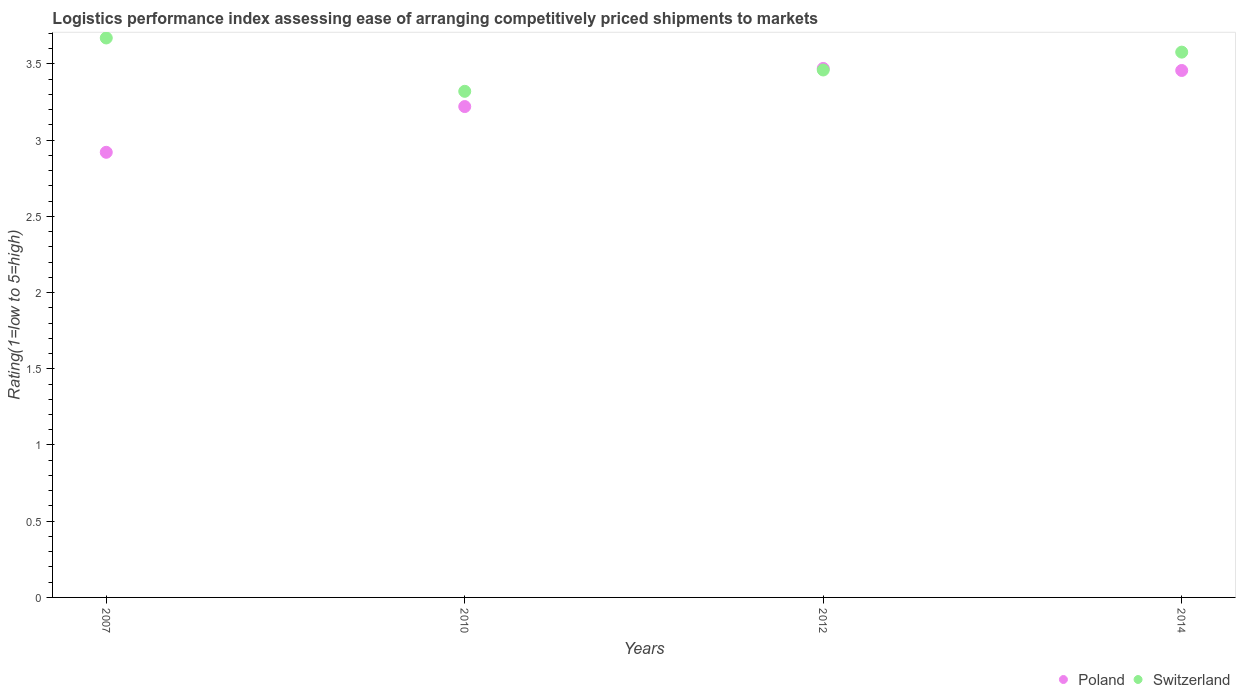Is the number of dotlines equal to the number of legend labels?
Make the answer very short. Yes. What is the Logistic performance index in Switzerland in 2007?
Provide a short and direct response. 3.67. Across all years, what is the maximum Logistic performance index in Switzerland?
Provide a succinct answer. 3.67. Across all years, what is the minimum Logistic performance index in Switzerland?
Offer a terse response. 3.32. In which year was the Logistic performance index in Switzerland maximum?
Your response must be concise. 2007. What is the total Logistic performance index in Switzerland in the graph?
Your answer should be very brief. 14.03. What is the difference between the Logistic performance index in Switzerland in 2007 and that in 2014?
Provide a short and direct response. 0.09. What is the difference between the Logistic performance index in Switzerland in 2007 and the Logistic performance index in Poland in 2012?
Provide a succinct answer. 0.2. What is the average Logistic performance index in Poland per year?
Offer a terse response. 3.27. In the year 2014, what is the difference between the Logistic performance index in Switzerland and Logistic performance index in Poland?
Offer a terse response. 0.12. In how many years, is the Logistic performance index in Switzerland greater than 3?
Make the answer very short. 4. What is the ratio of the Logistic performance index in Switzerland in 2007 to that in 2010?
Keep it short and to the point. 1.11. What is the difference between the highest and the second highest Logistic performance index in Switzerland?
Ensure brevity in your answer.  0.09. What is the difference between the highest and the lowest Logistic performance index in Poland?
Ensure brevity in your answer.  0.55. In how many years, is the Logistic performance index in Poland greater than the average Logistic performance index in Poland taken over all years?
Give a very brief answer. 2. Does the Logistic performance index in Poland monotonically increase over the years?
Ensure brevity in your answer.  No. Is the Logistic performance index in Poland strictly less than the Logistic performance index in Switzerland over the years?
Make the answer very short. No. How many dotlines are there?
Your answer should be very brief. 2. How many years are there in the graph?
Your answer should be very brief. 4. Are the values on the major ticks of Y-axis written in scientific E-notation?
Provide a succinct answer. No. How are the legend labels stacked?
Give a very brief answer. Horizontal. What is the title of the graph?
Your answer should be compact. Logistics performance index assessing ease of arranging competitively priced shipments to markets. Does "El Salvador" appear as one of the legend labels in the graph?
Ensure brevity in your answer.  No. What is the label or title of the X-axis?
Keep it short and to the point. Years. What is the label or title of the Y-axis?
Offer a terse response. Rating(1=low to 5=high). What is the Rating(1=low to 5=high) of Poland in 2007?
Ensure brevity in your answer.  2.92. What is the Rating(1=low to 5=high) in Switzerland in 2007?
Provide a succinct answer. 3.67. What is the Rating(1=low to 5=high) in Poland in 2010?
Ensure brevity in your answer.  3.22. What is the Rating(1=low to 5=high) in Switzerland in 2010?
Provide a short and direct response. 3.32. What is the Rating(1=low to 5=high) of Poland in 2012?
Make the answer very short. 3.47. What is the Rating(1=low to 5=high) of Switzerland in 2012?
Make the answer very short. 3.46. What is the Rating(1=low to 5=high) in Poland in 2014?
Ensure brevity in your answer.  3.46. What is the Rating(1=low to 5=high) in Switzerland in 2014?
Your answer should be very brief. 3.58. Across all years, what is the maximum Rating(1=low to 5=high) of Poland?
Give a very brief answer. 3.47. Across all years, what is the maximum Rating(1=low to 5=high) in Switzerland?
Provide a short and direct response. 3.67. Across all years, what is the minimum Rating(1=low to 5=high) in Poland?
Provide a succinct answer. 2.92. Across all years, what is the minimum Rating(1=low to 5=high) in Switzerland?
Provide a succinct answer. 3.32. What is the total Rating(1=low to 5=high) of Poland in the graph?
Keep it short and to the point. 13.07. What is the total Rating(1=low to 5=high) in Switzerland in the graph?
Offer a terse response. 14.03. What is the difference between the Rating(1=low to 5=high) of Poland in 2007 and that in 2010?
Your response must be concise. -0.3. What is the difference between the Rating(1=low to 5=high) of Switzerland in 2007 and that in 2010?
Your answer should be very brief. 0.35. What is the difference between the Rating(1=low to 5=high) of Poland in 2007 and that in 2012?
Make the answer very short. -0.55. What is the difference between the Rating(1=low to 5=high) of Switzerland in 2007 and that in 2012?
Provide a short and direct response. 0.21. What is the difference between the Rating(1=low to 5=high) of Poland in 2007 and that in 2014?
Your answer should be very brief. -0.54. What is the difference between the Rating(1=low to 5=high) in Switzerland in 2007 and that in 2014?
Your answer should be very brief. 0.09. What is the difference between the Rating(1=low to 5=high) of Switzerland in 2010 and that in 2012?
Your answer should be compact. -0.14. What is the difference between the Rating(1=low to 5=high) of Poland in 2010 and that in 2014?
Offer a terse response. -0.24. What is the difference between the Rating(1=low to 5=high) of Switzerland in 2010 and that in 2014?
Provide a succinct answer. -0.26. What is the difference between the Rating(1=low to 5=high) in Poland in 2012 and that in 2014?
Keep it short and to the point. 0.01. What is the difference between the Rating(1=low to 5=high) of Switzerland in 2012 and that in 2014?
Your answer should be very brief. -0.12. What is the difference between the Rating(1=low to 5=high) of Poland in 2007 and the Rating(1=low to 5=high) of Switzerland in 2010?
Provide a succinct answer. -0.4. What is the difference between the Rating(1=low to 5=high) of Poland in 2007 and the Rating(1=low to 5=high) of Switzerland in 2012?
Keep it short and to the point. -0.54. What is the difference between the Rating(1=low to 5=high) in Poland in 2007 and the Rating(1=low to 5=high) in Switzerland in 2014?
Ensure brevity in your answer.  -0.66. What is the difference between the Rating(1=low to 5=high) in Poland in 2010 and the Rating(1=low to 5=high) in Switzerland in 2012?
Provide a succinct answer. -0.24. What is the difference between the Rating(1=low to 5=high) of Poland in 2010 and the Rating(1=low to 5=high) of Switzerland in 2014?
Your answer should be compact. -0.36. What is the difference between the Rating(1=low to 5=high) in Poland in 2012 and the Rating(1=low to 5=high) in Switzerland in 2014?
Ensure brevity in your answer.  -0.11. What is the average Rating(1=low to 5=high) in Poland per year?
Make the answer very short. 3.27. What is the average Rating(1=low to 5=high) of Switzerland per year?
Give a very brief answer. 3.51. In the year 2007, what is the difference between the Rating(1=low to 5=high) of Poland and Rating(1=low to 5=high) of Switzerland?
Offer a very short reply. -0.75. In the year 2014, what is the difference between the Rating(1=low to 5=high) in Poland and Rating(1=low to 5=high) in Switzerland?
Make the answer very short. -0.12. What is the ratio of the Rating(1=low to 5=high) of Poland in 2007 to that in 2010?
Keep it short and to the point. 0.91. What is the ratio of the Rating(1=low to 5=high) in Switzerland in 2007 to that in 2010?
Your answer should be very brief. 1.11. What is the ratio of the Rating(1=low to 5=high) in Poland in 2007 to that in 2012?
Your answer should be very brief. 0.84. What is the ratio of the Rating(1=low to 5=high) of Switzerland in 2007 to that in 2012?
Offer a very short reply. 1.06. What is the ratio of the Rating(1=low to 5=high) of Poland in 2007 to that in 2014?
Provide a succinct answer. 0.84. What is the ratio of the Rating(1=low to 5=high) in Poland in 2010 to that in 2012?
Make the answer very short. 0.93. What is the ratio of the Rating(1=low to 5=high) of Switzerland in 2010 to that in 2012?
Your answer should be compact. 0.96. What is the ratio of the Rating(1=low to 5=high) in Poland in 2010 to that in 2014?
Your answer should be very brief. 0.93. What is the ratio of the Rating(1=low to 5=high) in Switzerland in 2010 to that in 2014?
Offer a very short reply. 0.93. What is the ratio of the Rating(1=low to 5=high) of Poland in 2012 to that in 2014?
Provide a short and direct response. 1. What is the ratio of the Rating(1=low to 5=high) in Switzerland in 2012 to that in 2014?
Provide a succinct answer. 0.97. What is the difference between the highest and the second highest Rating(1=low to 5=high) of Poland?
Make the answer very short. 0.01. What is the difference between the highest and the second highest Rating(1=low to 5=high) of Switzerland?
Your answer should be compact. 0.09. What is the difference between the highest and the lowest Rating(1=low to 5=high) of Poland?
Make the answer very short. 0.55. 